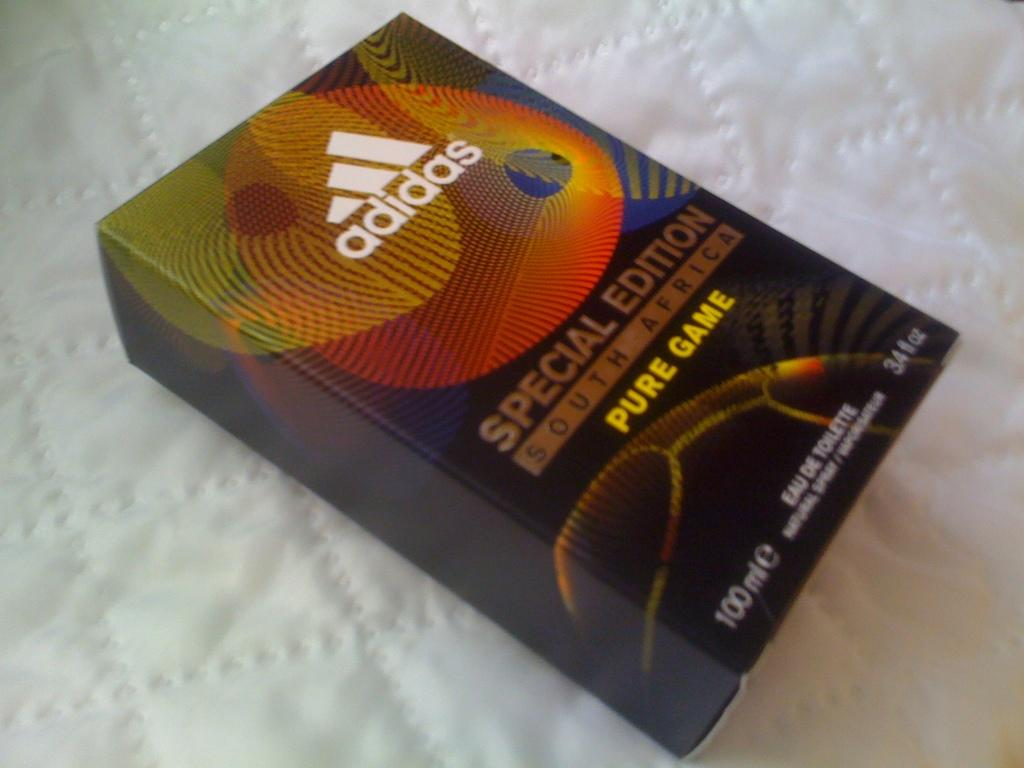<image>
Present a compact description of the photo's key features. A box from the company adidas contains Pure Game Eau De Toilette. 